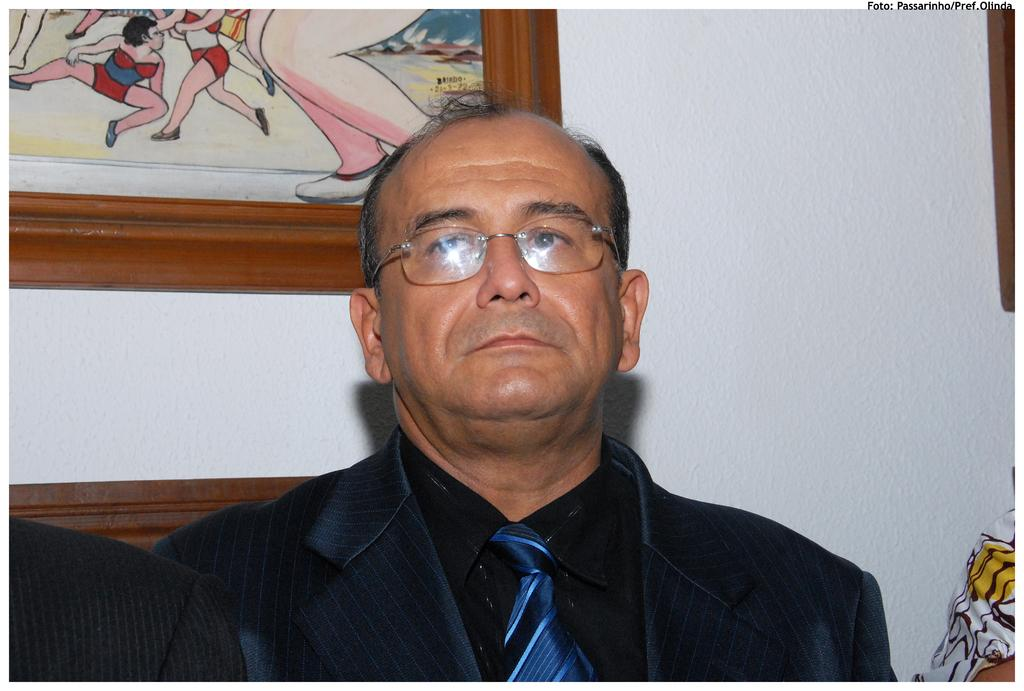Who is present in the image? There is a man in the image. What is the man wearing? The man is wearing clothes, a tie, and spectacles. What can be seen in the background of the image? There is a frame and a wall in the image. Are there any other people in the image? Yes, there are people sitting beside the man. What type of flowers are on the calendar in the image? There is no calendar or flowers present in the image. 